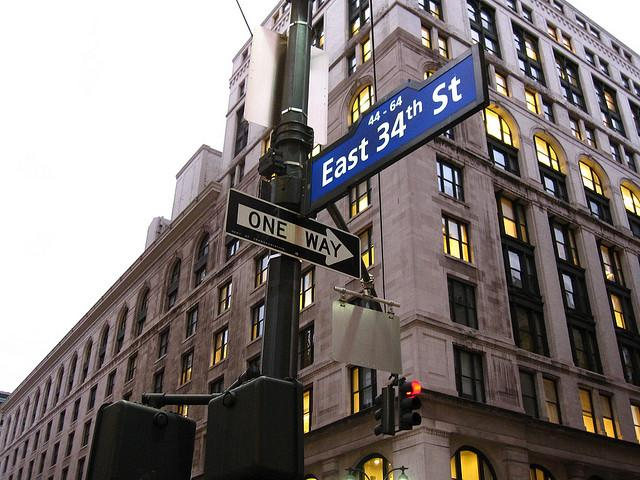What are is the image from?

Choices:
A) city
B) forest
C) sky
D) underground city 